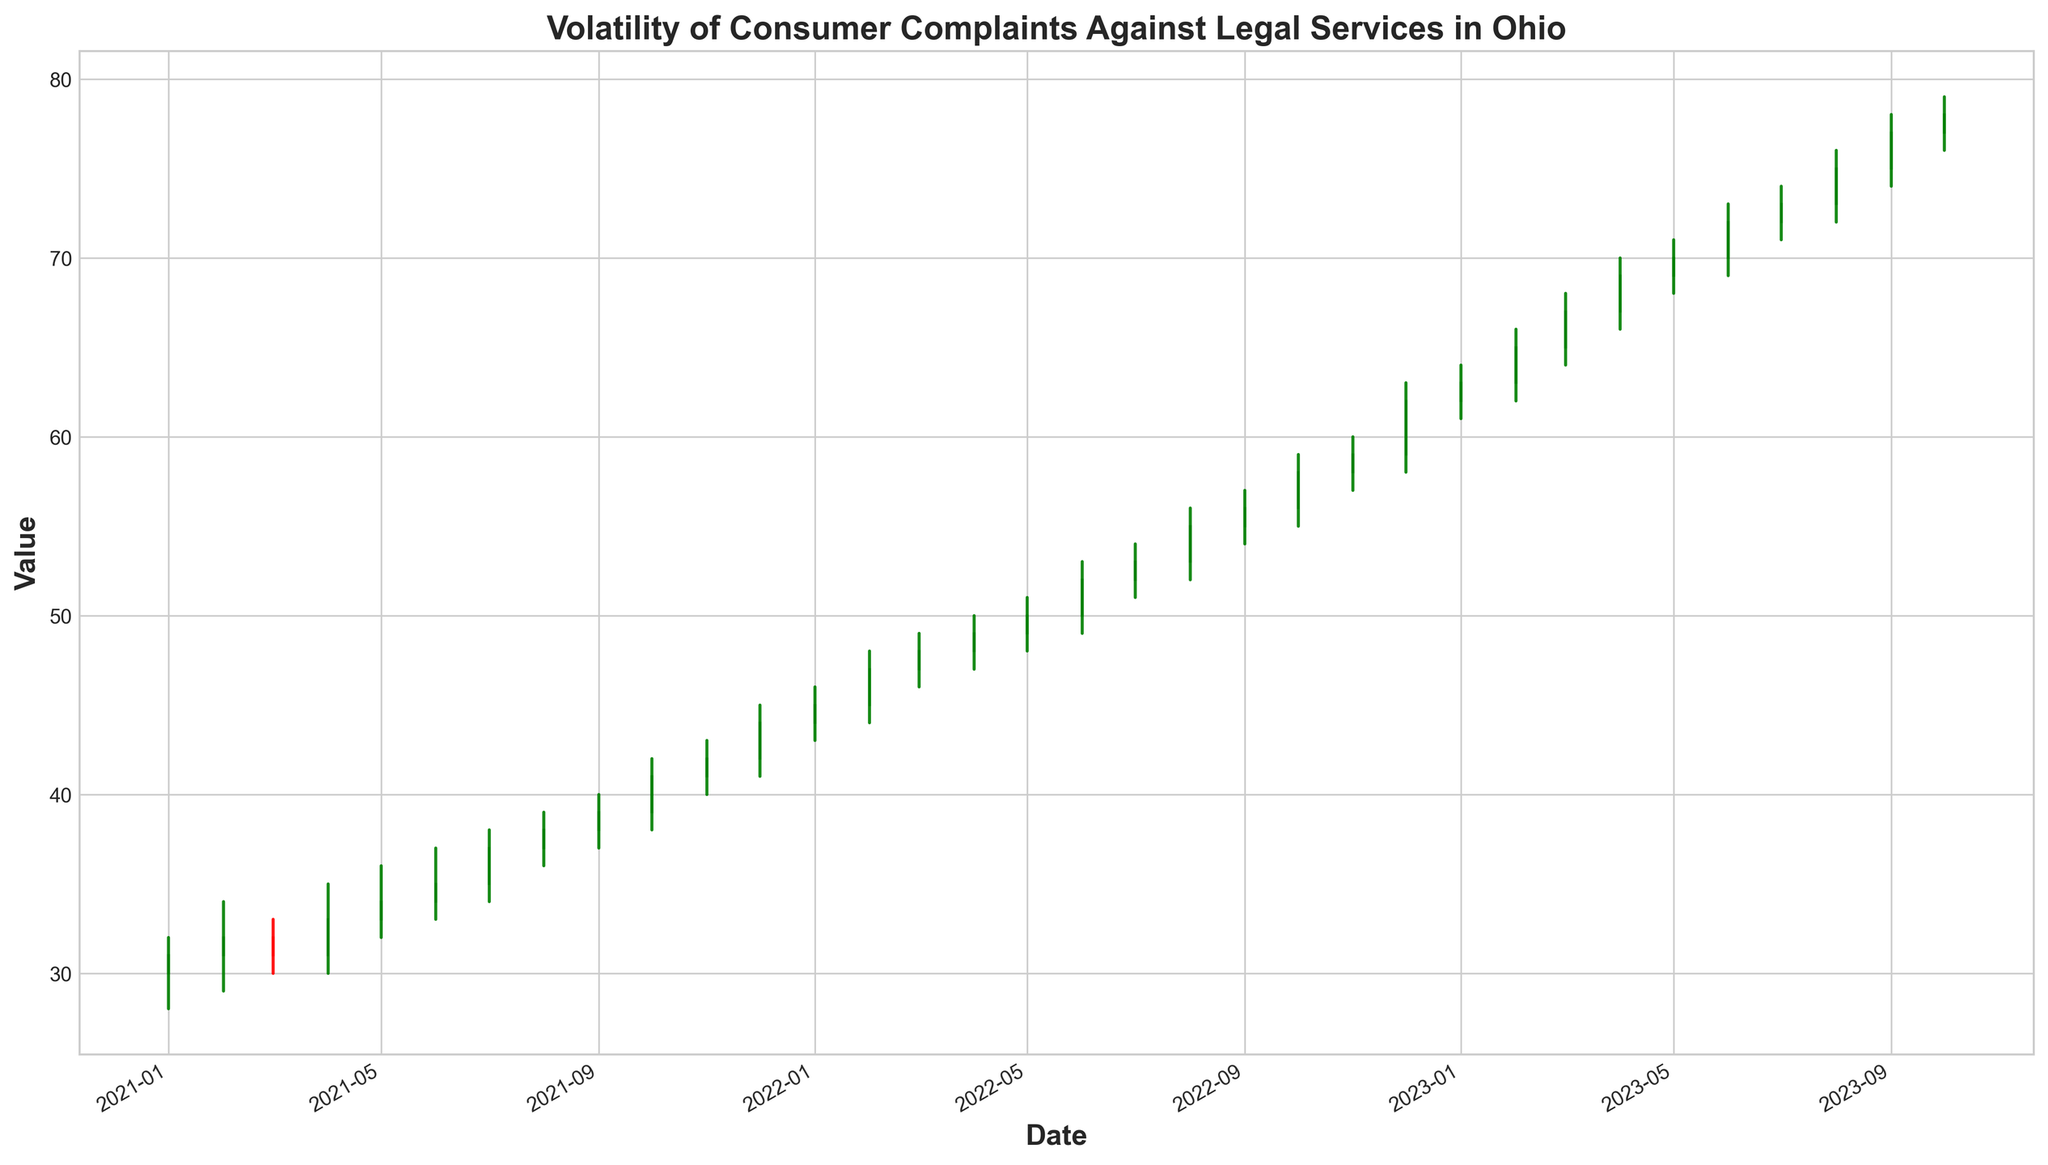What was the highest value in 2021? Looking at the 2021 data points, the highest "High" value occurred in December 2021 with a value of 45.
Answer: 45 Which month had the highest number of complaints in 2022? Volume represents the number of complaints. Among all months in 2022, December had the highest volume of 240 complaints.
Answer: December Did the closing value in August 2023 increase, decrease, or remain constant compared to July 2023? The closing value in July 2023 was 73, and in August 2023, it was 75, showing an increase.
Answer: Increased Which period had the most consistent month-to-month close values in 2021? By observing the closing values through the months of 2021, the period from January to March (31, 32, 31) shows the least fluctuation, indicating consistency.
Answer: January to March Compare the lowest value in January 2022 to the lowest value in January 2023. Which is lower? The lowest value in January 2022 was 43, and in January 2023 it was 61. The lowest in January 2022 is lower.
Answer: January 2022 What's the average closing value of 2022? The closing values for the twelve months in 2022 are summed up to get 651. Dividing this by 12 gives an average closing value: 651/12 ≈ 54.25.
Answer: 54.25 Identify the longest green candle in 2021. Green candles occur when the closing value is higher than the opening value. In 2021, the longest green candle is October with a height of 41 - 39 = 2.
Answer: October What was the relative change in volume from October to November 2023? The volume in October 2023 was 300 and in November 2023 it was 235. The relative change is calculated as (235 - 300) / 300 * 100% ≈ -21.67%.
Answer: -21.67% Which month in 2023 had its "Low" value closest to 71? Closest to 71 in 2023 would be July, with a low of 71 exactly.
Answer: July Between 2021 and 2023, which year shows the highest increase in complaints volume by year's end? Comparing volumes at year's end: December 2021 (180), December 2022 (240), December 2023 (300). The highest increase occurred between 2021 and 2022 with an increase of 60.
Answer: 2022 